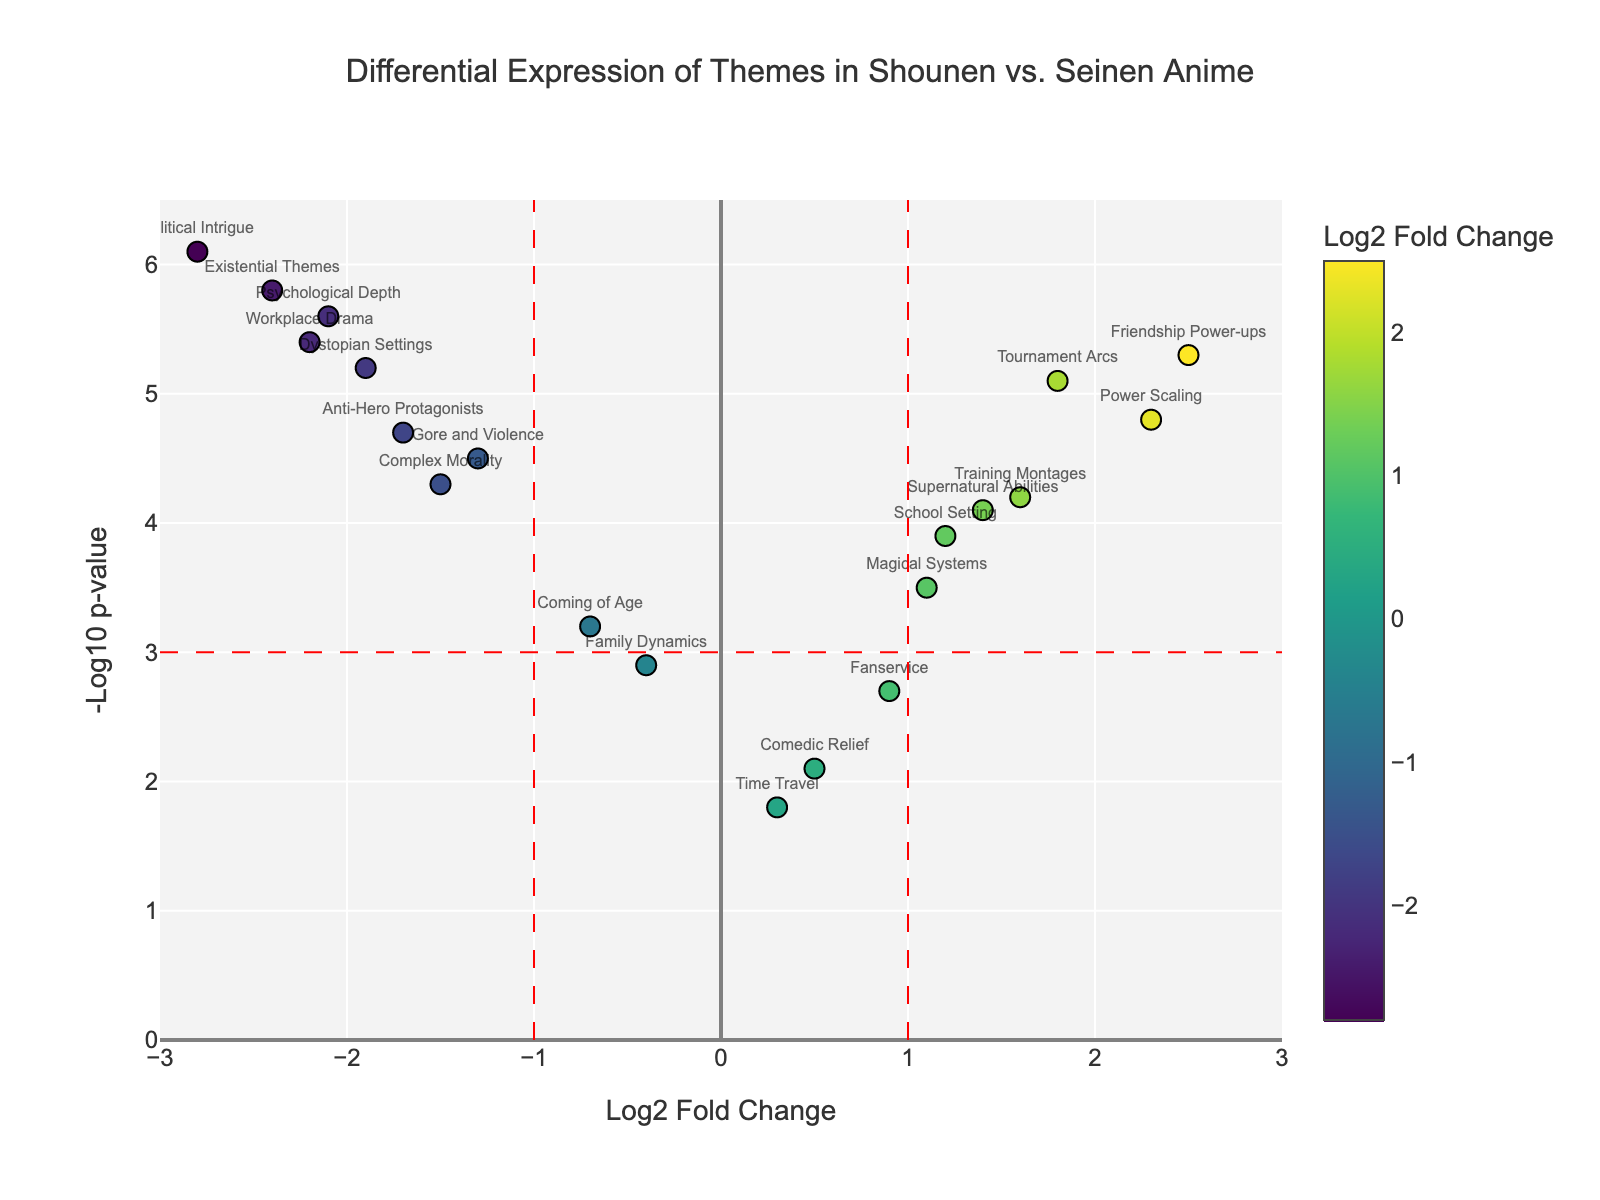what is the theme with the highest Log2 Fold Change? The Volcano Plot displays themes as points. The point with the highest Log2 Fold Change (furthest to the right on the x-axis) is "Friendship Power-ups" with a Log2FC of 2.5.
Answer: Friendship Power-ups what does the Log2 Fold Change represent? Log2 Fold Change represents the ratio of the expression of a theme in shounen anime to its expression in seinen anime. A higher Log2 Fold Change indicates a higher prevalence in shounen anime and vice versa.
Answer: Ratio of theme expression how many themes have a significant differential expression (p-value < 0.05)? Themes with a -Log10 p-value above 3 (equivalent to p-value < 0.05) and beyond the vertical lines at Log2 Fold Change of -1 and 1 are deemed significant. Counting these points gives 11 themes.
Answer: 11 which themes show a significant differential expression leaning towards seinen anime? Themes with significant differential expression that have Log2 Fold Change less than -1 (leaning towards seinen) and -Log10 p-value above 3 are "Psychological Depth," "Political Intrigue," "Existential Themes," and "Workplace Drama."
Answer: Psychological Depth, Political Intrigue, Existential Themes, Workplace Drama is "Complex Morality" more common in shounen or seinen anime? The Volcano Plot shows "Complex Morality" with a Log2 Fold Change of -1.5, indicating it is more common in seinen anime (since Log2FC is negative).
Answer: Seinen what theme has the lowest -Log10 p-value among those higher in shounen anime? Among themes with positive Log2 Fold Change, "Comedic Relief" has the lowest -Log10 p-value of 2.1.
Answer: Comedic Relief which theme has the highest -Log10 p-value in the entire plot? The point representing the highest -Log10 p-value is for "Political Intrigue" with a value of 6.1, indicating the strongest statistical significance.
Answer: Political Intrigue how does "Fanservice" compare to "Magical Systems" in terms of shounen presence? "Fanservice" has a Log2 Fold Change of 0.9, while "Magical Systems" stands at 1.1. Since both have positive Log2 Fold Change values, "Magical Systems" is slightly more prevalent in shounen anime than "Fanservice."
Answer: Magical Systems which theme has the highest expression in shounen anime with a -Log10 p-value greater than 4? "Friendship Power-ups" has the highest Log2FC (2.5) among themes with a -Log10 p-value greater than 4, showing its significant presence in shounen anime.
Answer: Friendship Power-ups do any themes show no differential expression between shounen and seinen anime? A potential theme without differential expression would have a Log2 Fold Change close to 0. "Comedic Relief," with a Log2FC of 0.5, is the closest but still shows some differential expression.
Answer: None 